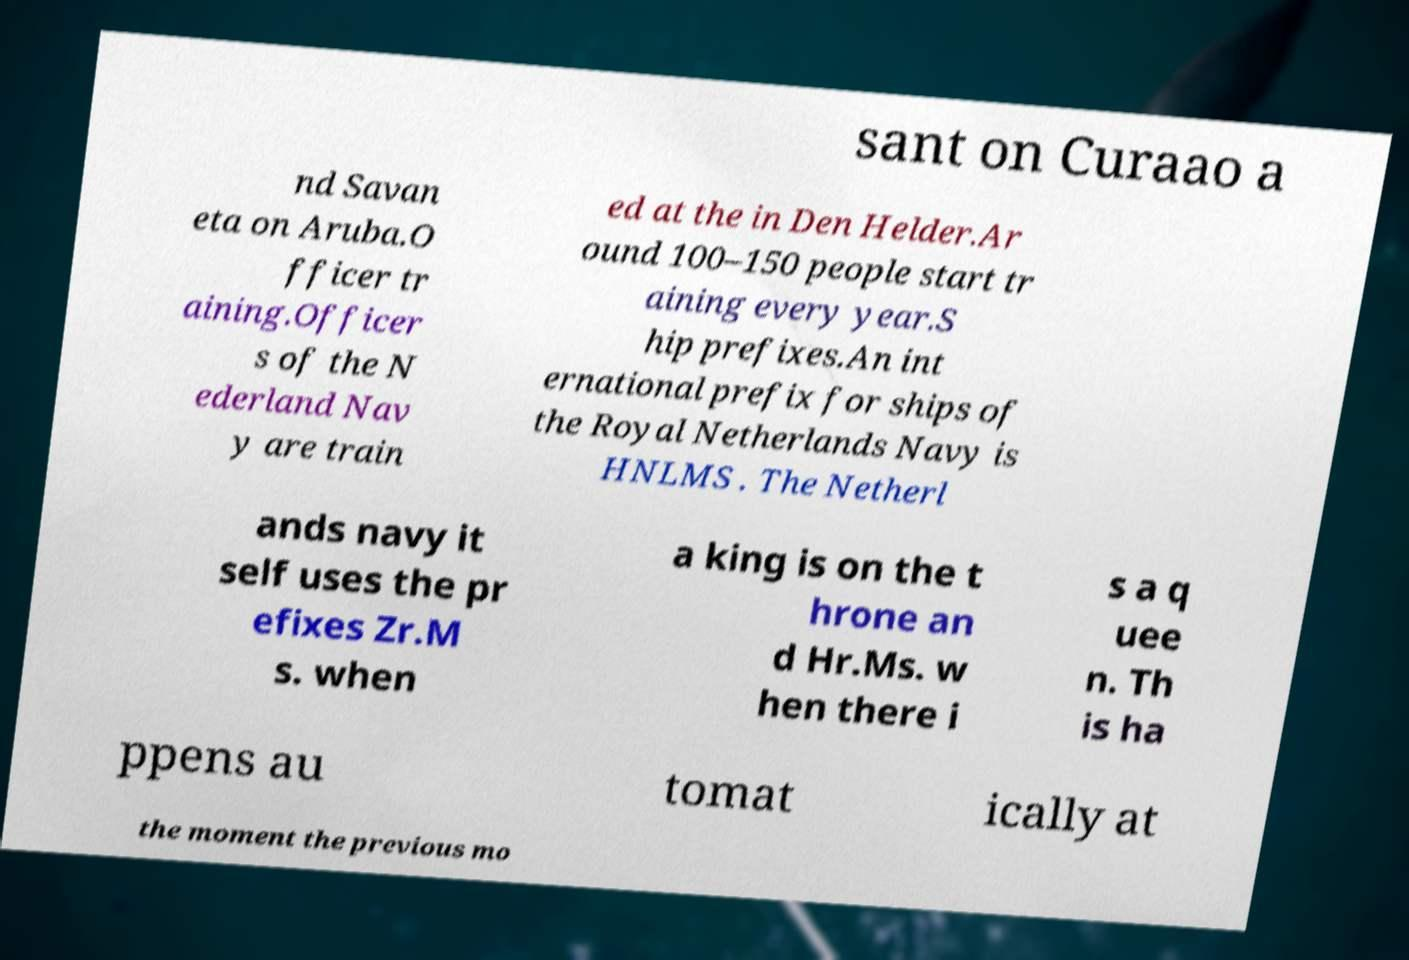I need the written content from this picture converted into text. Can you do that? sant on Curaao a nd Savan eta on Aruba.O fficer tr aining.Officer s of the N ederland Nav y are train ed at the in Den Helder.Ar ound 100–150 people start tr aining every year.S hip prefixes.An int ernational prefix for ships of the Royal Netherlands Navy is HNLMS . The Netherl ands navy it self uses the pr efixes Zr.M s. when a king is on the t hrone an d Hr.Ms. w hen there i s a q uee n. Th is ha ppens au tomat ically at the moment the previous mo 